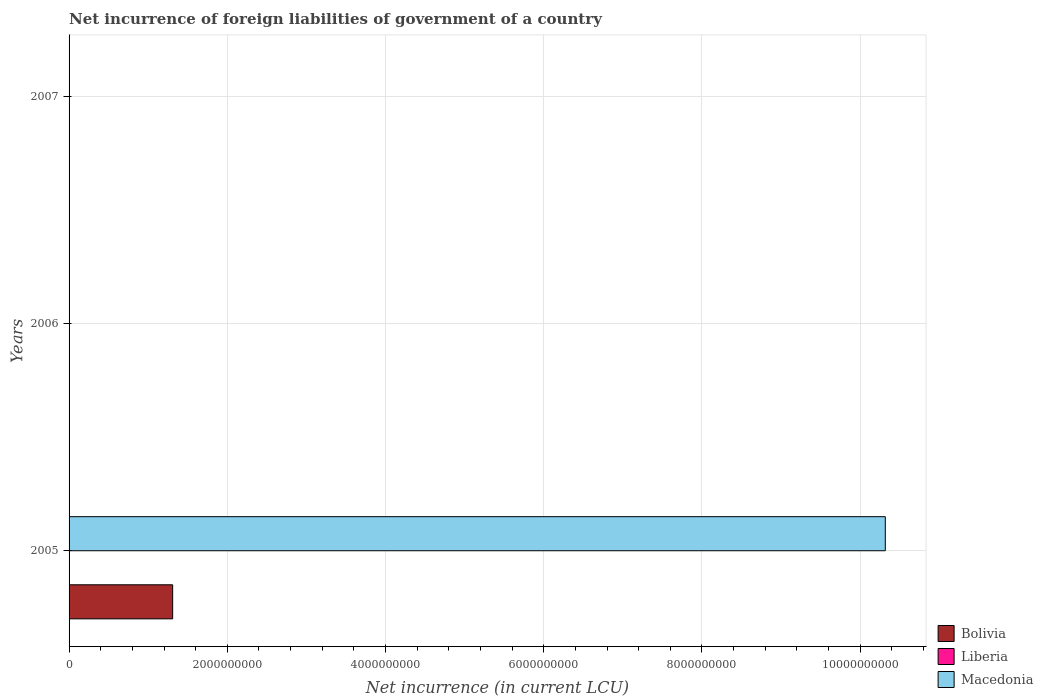How many different coloured bars are there?
Make the answer very short. 2. Are the number of bars per tick equal to the number of legend labels?
Your response must be concise. No. How many bars are there on the 2nd tick from the bottom?
Keep it short and to the point. 0. What is the net incurrence of foreign liabilities in Bolivia in 2005?
Your answer should be compact. 1.31e+09. Across all years, what is the maximum net incurrence of foreign liabilities in Bolivia?
Give a very brief answer. 1.31e+09. Across all years, what is the minimum net incurrence of foreign liabilities in Bolivia?
Ensure brevity in your answer.  0. What is the total net incurrence of foreign liabilities in Bolivia in the graph?
Your response must be concise. 1.31e+09. What is the difference between the net incurrence of foreign liabilities in Liberia in 2006 and the net incurrence of foreign liabilities in Bolivia in 2005?
Your response must be concise. -1.31e+09. What is the average net incurrence of foreign liabilities in Macedonia per year?
Give a very brief answer. 3.44e+09. In the year 2005, what is the difference between the net incurrence of foreign liabilities in Bolivia and net incurrence of foreign liabilities in Macedonia?
Give a very brief answer. -9.01e+09. In how many years, is the net incurrence of foreign liabilities in Bolivia greater than 9200000000 LCU?
Give a very brief answer. 0. What is the difference between the highest and the lowest net incurrence of foreign liabilities in Bolivia?
Your answer should be compact. 1.31e+09. Is it the case that in every year, the sum of the net incurrence of foreign liabilities in Liberia and net incurrence of foreign liabilities in Bolivia is greater than the net incurrence of foreign liabilities in Macedonia?
Provide a succinct answer. No. How many bars are there?
Your response must be concise. 2. Are the values on the major ticks of X-axis written in scientific E-notation?
Make the answer very short. No. Does the graph contain grids?
Offer a terse response. Yes. Where does the legend appear in the graph?
Your answer should be compact. Bottom right. How many legend labels are there?
Offer a terse response. 3. How are the legend labels stacked?
Make the answer very short. Vertical. What is the title of the graph?
Keep it short and to the point. Net incurrence of foreign liabilities of government of a country. What is the label or title of the X-axis?
Provide a short and direct response. Net incurrence (in current LCU). What is the label or title of the Y-axis?
Provide a succinct answer. Years. What is the Net incurrence (in current LCU) in Bolivia in 2005?
Make the answer very short. 1.31e+09. What is the Net incurrence (in current LCU) in Macedonia in 2005?
Provide a short and direct response. 1.03e+1. What is the Net incurrence (in current LCU) in Liberia in 2006?
Keep it short and to the point. 0. What is the Net incurrence (in current LCU) in Liberia in 2007?
Your response must be concise. 0. Across all years, what is the maximum Net incurrence (in current LCU) of Bolivia?
Ensure brevity in your answer.  1.31e+09. Across all years, what is the maximum Net incurrence (in current LCU) of Macedonia?
Ensure brevity in your answer.  1.03e+1. Across all years, what is the minimum Net incurrence (in current LCU) of Bolivia?
Provide a short and direct response. 0. What is the total Net incurrence (in current LCU) in Bolivia in the graph?
Your answer should be compact. 1.31e+09. What is the total Net incurrence (in current LCU) in Macedonia in the graph?
Ensure brevity in your answer.  1.03e+1. What is the average Net incurrence (in current LCU) in Bolivia per year?
Ensure brevity in your answer.  4.36e+08. What is the average Net incurrence (in current LCU) of Liberia per year?
Keep it short and to the point. 0. What is the average Net incurrence (in current LCU) of Macedonia per year?
Give a very brief answer. 3.44e+09. In the year 2005, what is the difference between the Net incurrence (in current LCU) in Bolivia and Net incurrence (in current LCU) in Macedonia?
Make the answer very short. -9.01e+09. What is the difference between the highest and the lowest Net incurrence (in current LCU) of Bolivia?
Provide a succinct answer. 1.31e+09. What is the difference between the highest and the lowest Net incurrence (in current LCU) in Macedonia?
Keep it short and to the point. 1.03e+1. 